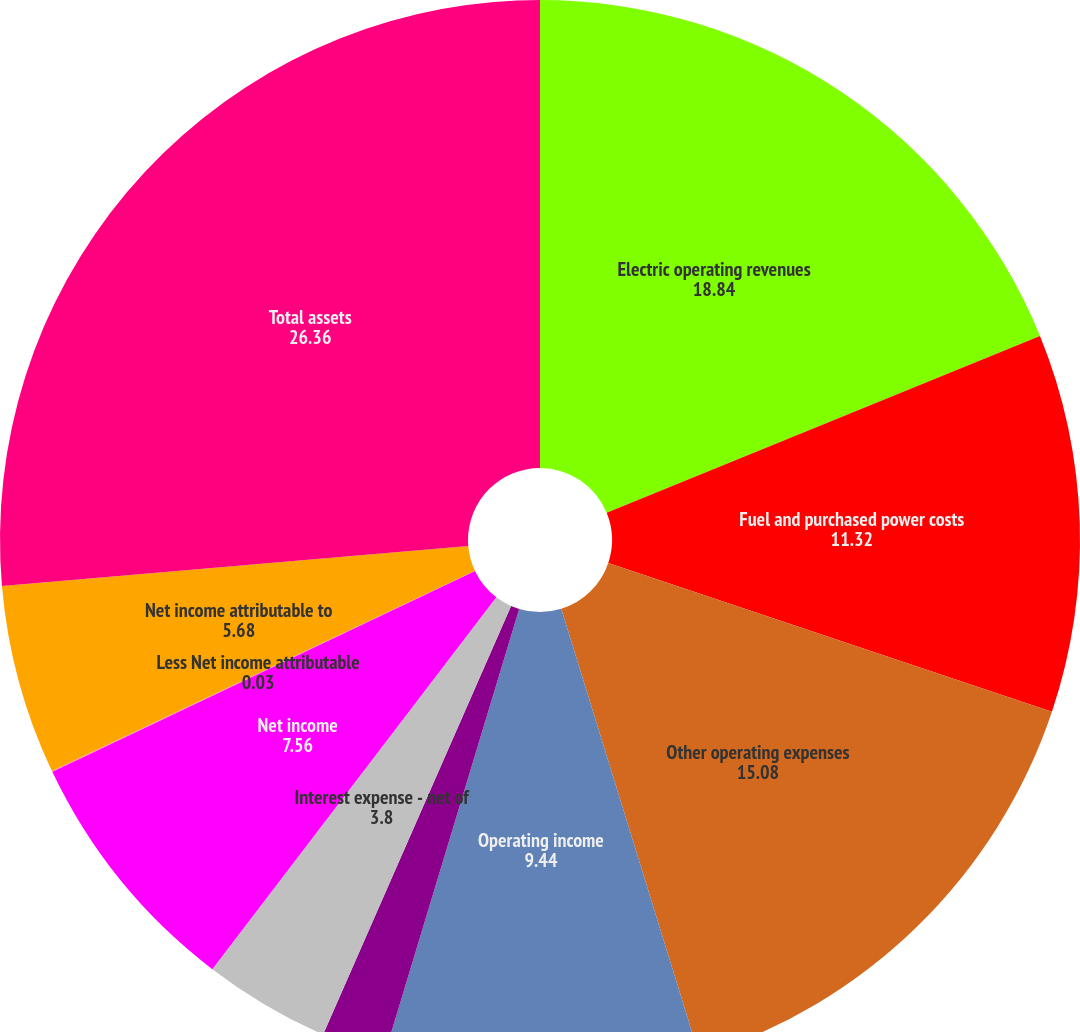Convert chart to OTSL. <chart><loc_0><loc_0><loc_500><loc_500><pie_chart><fcel>Electric operating revenues<fcel>Fuel and purchased power costs<fcel>Other operating expenses<fcel>Operating income<fcel>Other income<fcel>Interest expense - net of<fcel>Net income<fcel>Less Net income attributable<fcel>Net income attributable to<fcel>Total assets<nl><fcel>18.84%<fcel>11.32%<fcel>15.08%<fcel>9.44%<fcel>1.91%<fcel>3.8%<fcel>7.56%<fcel>0.03%<fcel>5.68%<fcel>26.36%<nl></chart> 